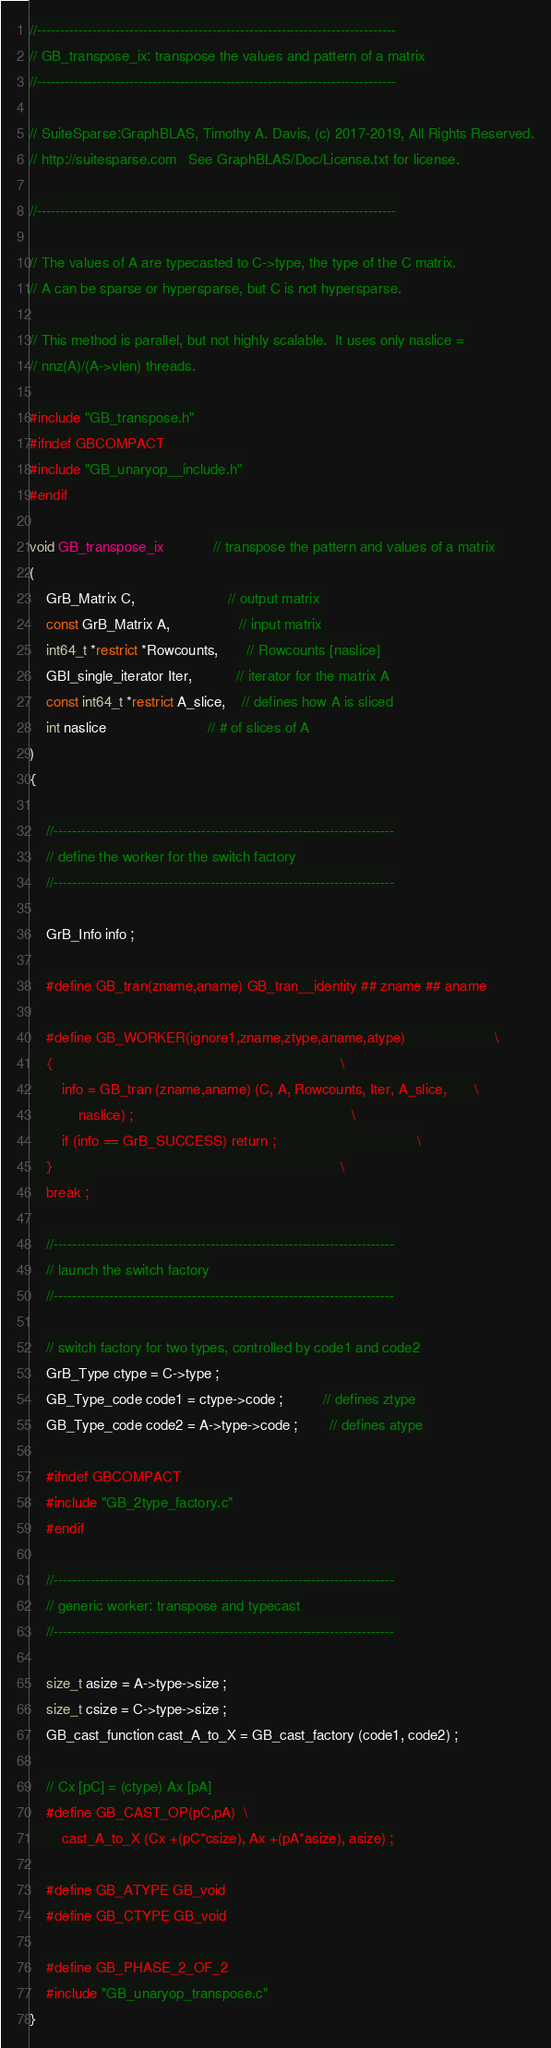<code> <loc_0><loc_0><loc_500><loc_500><_C_>//------------------------------------------------------------------------------
// GB_transpose_ix: transpose the values and pattern of a matrix
//------------------------------------------------------------------------------

// SuiteSparse:GraphBLAS, Timothy A. Davis, (c) 2017-2019, All Rights Reserved.
// http://suitesparse.com   See GraphBLAS/Doc/License.txt for license.

//------------------------------------------------------------------------------

// The values of A are typecasted to C->type, the type of the C matrix.
// A can be sparse or hypersparse, but C is not hypersparse.

// This method is parallel, but not highly scalable.  It uses only naslice =
// nnz(A)/(A->vlen) threads.

#include "GB_transpose.h"
#ifndef GBCOMPACT
#include "GB_unaryop__include.h"
#endif

void GB_transpose_ix            // transpose the pattern and values of a matrix
(
    GrB_Matrix C,                       // output matrix
    const GrB_Matrix A,                 // input matrix
    int64_t *restrict *Rowcounts,       // Rowcounts [naslice]
    GBI_single_iterator Iter,           // iterator for the matrix A
    const int64_t *restrict A_slice,    // defines how A is sliced
    int naslice                         // # of slices of A
)
{ 

    //--------------------------------------------------------------------------
    // define the worker for the switch factory
    //--------------------------------------------------------------------------

    GrB_Info info ;

    #define GB_tran(zname,aname) GB_tran__identity ## zname ## aname

    #define GB_WORKER(ignore1,zname,ztype,aname,atype)                      \
    {                                                                       \
        info = GB_tran (zname,aname) (C, A, Rowcounts, Iter, A_slice,       \
            naslice) ;                                                      \
        if (info == GrB_SUCCESS) return ;                                   \
    }                                                                       \
    break ;

    //--------------------------------------------------------------------------
    // launch the switch factory
    //--------------------------------------------------------------------------

    // switch factory for two types, controlled by code1 and code2
    GrB_Type ctype = C->type ;
    GB_Type_code code1 = ctype->code ;          // defines ztype
    GB_Type_code code2 = A->type->code ;        // defines atype

    #ifndef GBCOMPACT
    #include "GB_2type_factory.c"
    #endif

    //--------------------------------------------------------------------------
    // generic worker: transpose and typecast
    //--------------------------------------------------------------------------

    size_t asize = A->type->size ;
    size_t csize = C->type->size ;
    GB_cast_function cast_A_to_X = GB_cast_factory (code1, code2) ;

    // Cx [pC] = (ctype) Ax [pA]
    #define GB_CAST_OP(pC,pA)  \
        cast_A_to_X (Cx +(pC*csize), Ax +(pA*asize), asize) ;

    #define GB_ATYPE GB_void
    #define GB_CTYPE GB_void

    #define GB_PHASE_2_OF_2
    #include "GB_unaryop_transpose.c"
}

</code> 